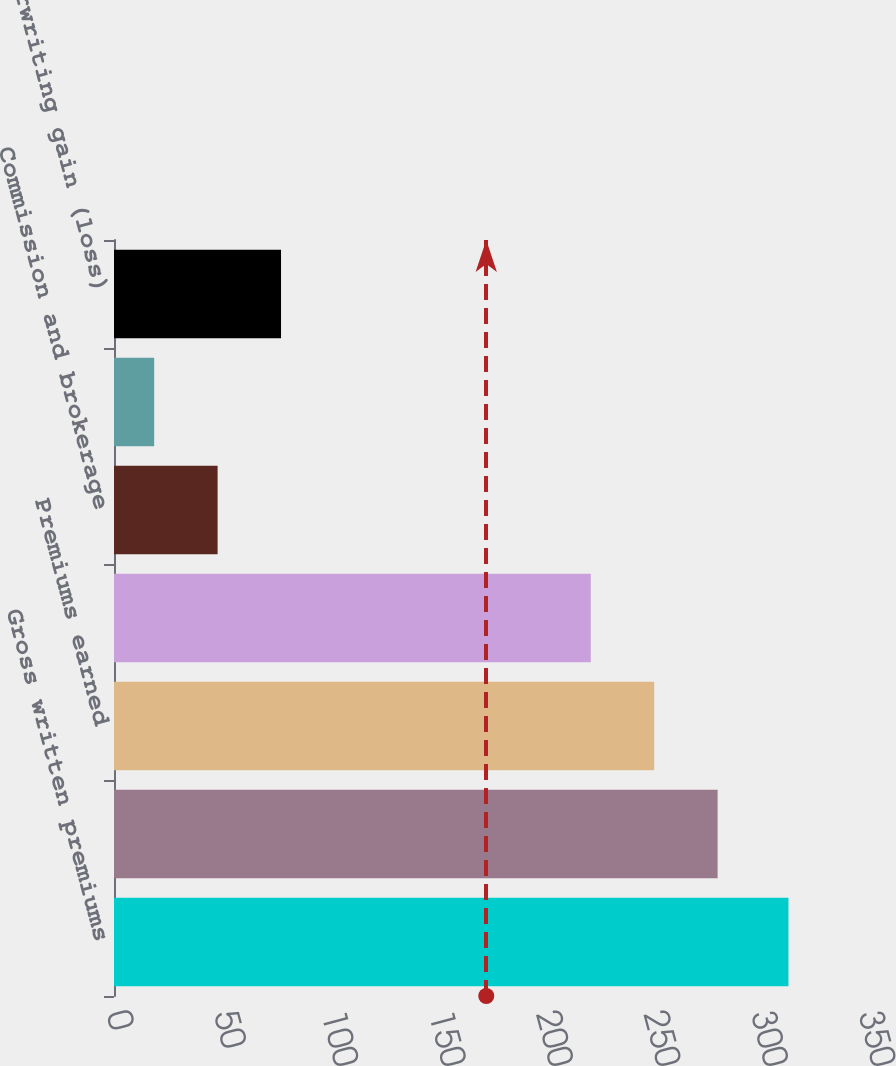Convert chart. <chart><loc_0><loc_0><loc_500><loc_500><bar_chart><fcel>Gross written premiums<fcel>Net written premiums<fcel>Premiums earned<fcel>Incurred losses and LAE<fcel>Commission and brokerage<fcel>Other underwriting expenses<fcel>Underwriting gain (loss)<nl><fcel>313.9<fcel>280.94<fcel>251.42<fcel>221.9<fcel>48.22<fcel>18.7<fcel>77.74<nl></chart> 